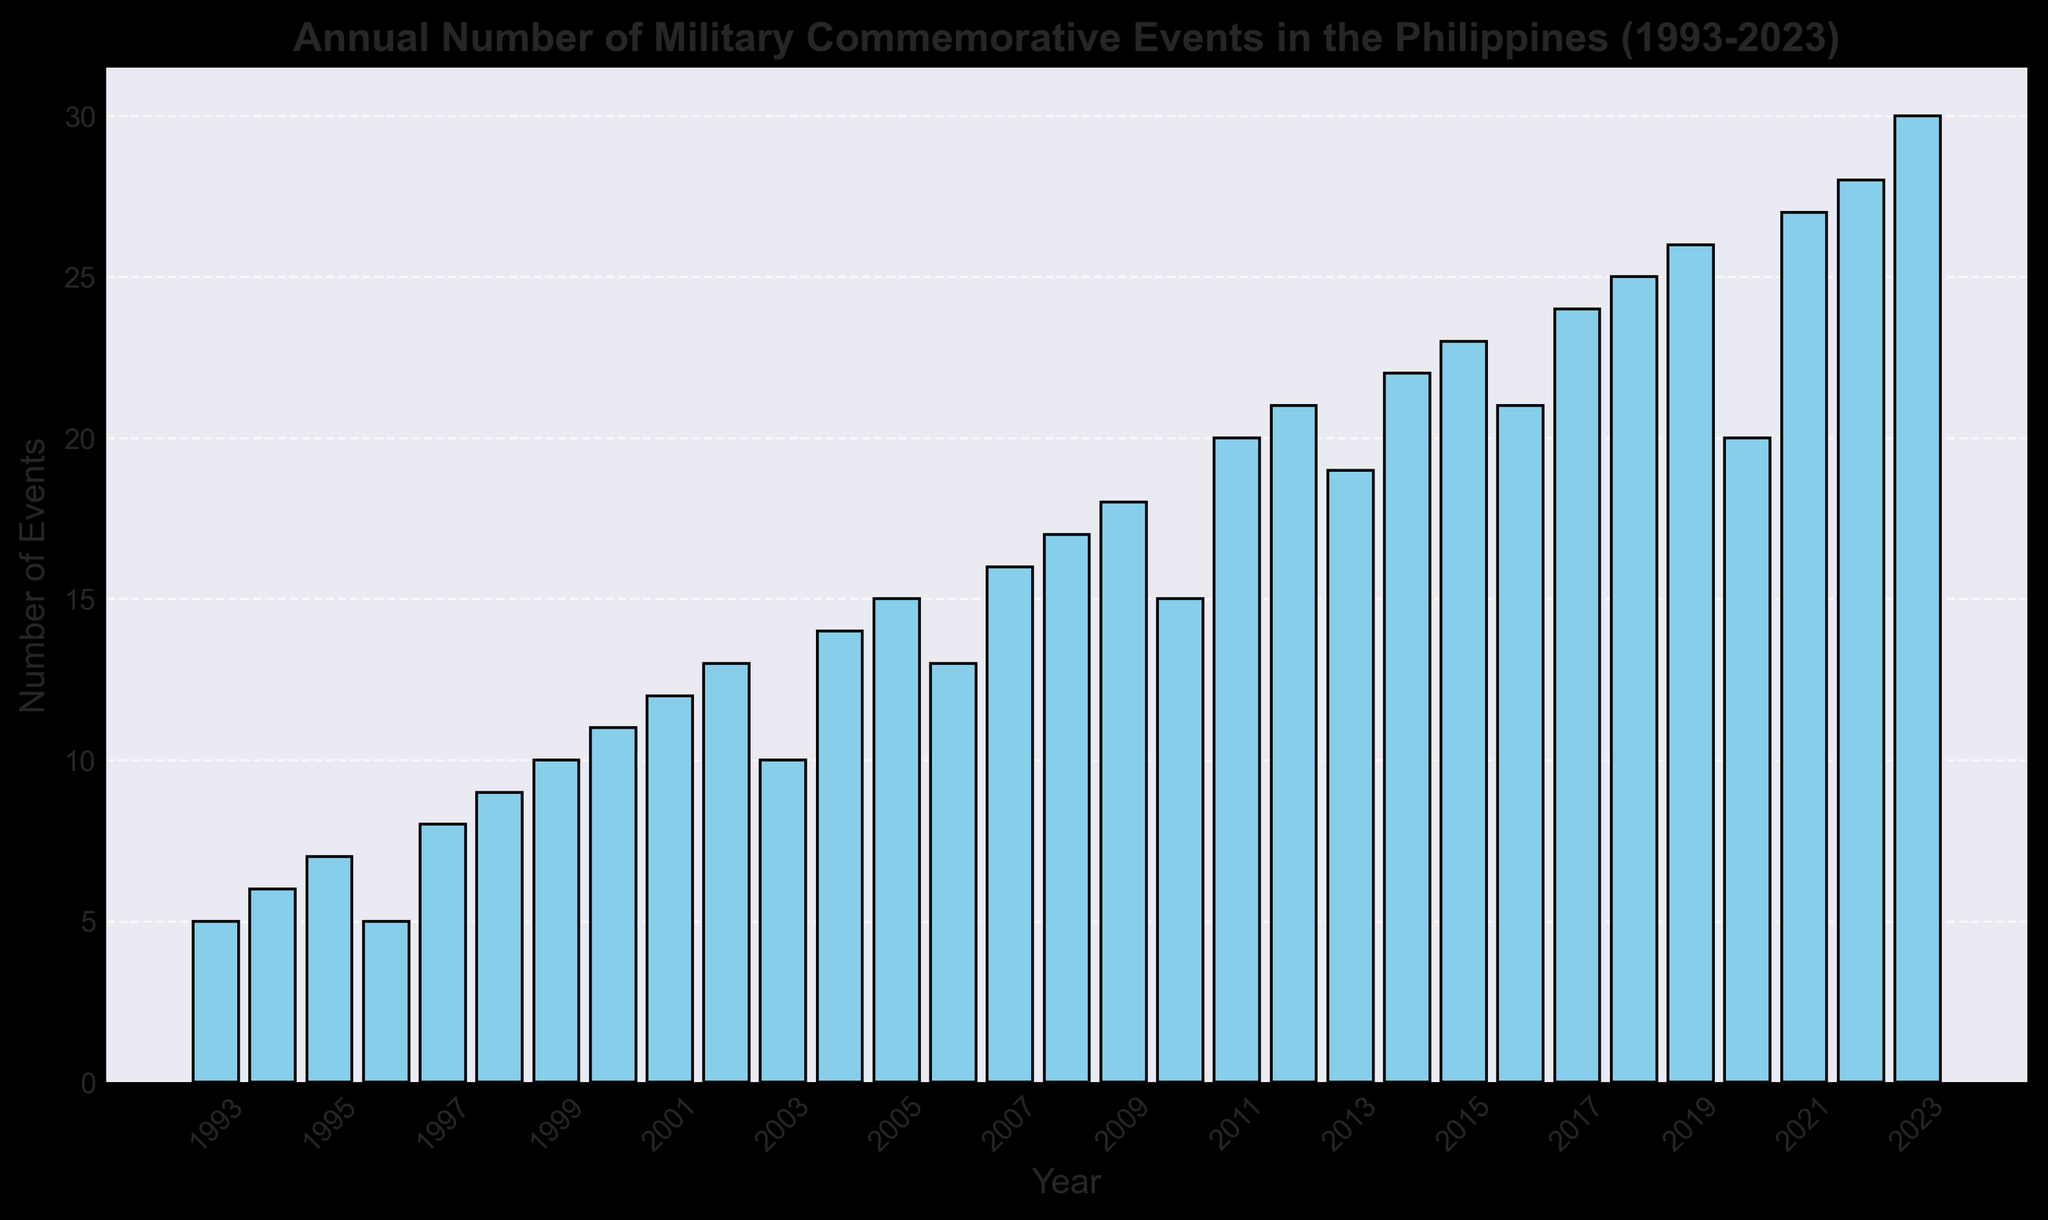Which year had the highest number of military commemorative events? By looking at the height of the bars, the highest bar corresponds to the year 2023.
Answer: 2023 How many military commemorative events were held in 2005? Find the bar corresponding to the year 2005 and look at its height to determine the number of events.
Answer: 15 What is the difference in the number of events between 1993 and 2023? Subtract the number of events in 1993 (5) from the number of events in 2023 (30).
Answer: 25 Which year had fewer events, 2002 or 2020? Compare the heights of the bars for the years 2002 (13 events) and 2020 (20 events).
Answer: 2002 What is the average number of events held annually from 2010 to 2020? Add the number of events from 2010 to 2020 and divide by the number of years (11). (15+20+21+19+22+23+21+24+25+26+20) / 11 = 216 / 11
Answer: 19.64 Did the number of events increase or decrease from 1996 to 1997? Compare the height of the bars for 1996 (5 events) and 1997 (8 events).
Answer: Increase How many more events were there in 2008 compared to 2006? Subtract the number of events in 2006 (13) from the number in 2008 (17).
Answer: 4 What is the median number of events held annually from 1993 to 2023? Arrange the number of events in ascending order and find the middle value. The data set has 31 years, so the median is the 16th value.
Answer: 16 Which decade saw the greatest increase in the number of events, the 1990s or the 2000s? Calculate the difference between the start and end years of each decade: 2000 (11) - 1993 (5) for the 1990s which is 6, and 2010 (15) - 2000 (11) for the 2000s which is 4.
Answer: 1990s How many years had more than 20 events? Count the bars with a height greater than 20.
Answer: 8 